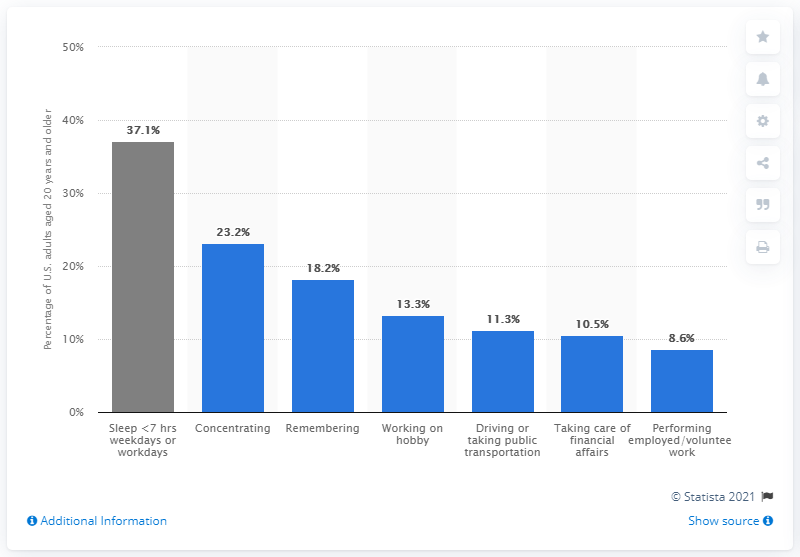Highlight a few significant elements in this photo. According to the data, 23.2% of respondents reported difficulty focusing or concentrating. 